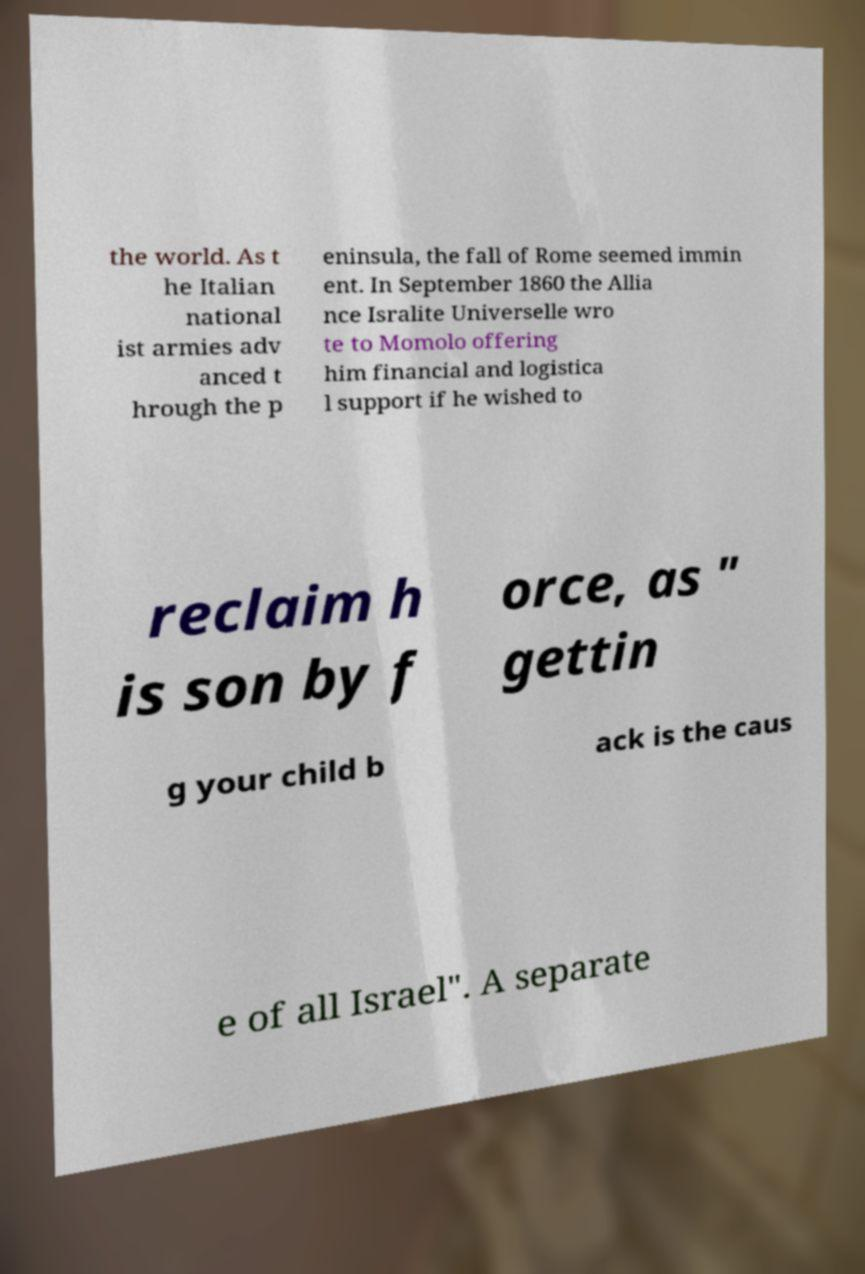Please read and relay the text visible in this image. What does it say? the world. As t he Italian national ist armies adv anced t hrough the p eninsula, the fall of Rome seemed immin ent. In September 1860 the Allia nce Isralite Universelle wro te to Momolo offering him financial and logistica l support if he wished to reclaim h is son by f orce, as " gettin g your child b ack is the caus e of all Israel". A separate 